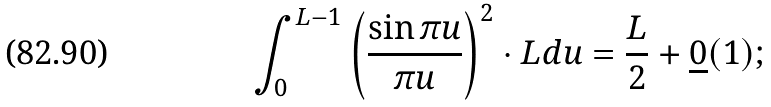Convert formula to latex. <formula><loc_0><loc_0><loc_500><loc_500>\int ^ { L - 1 } _ { 0 } \left ( \frac { \sin \pi u } { \pi u } \right ) ^ { 2 } \cdot L d u = \frac { L } { 2 } + \underline { 0 } ( 1 ) ;</formula> 